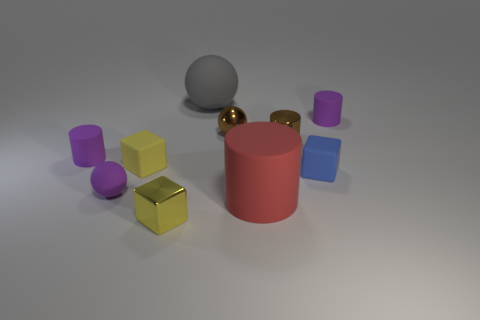How many purple cylinders must be subtracted to get 1 purple cylinders? 1 Subtract all tiny matte cubes. How many cubes are left? 1 Subtract all cyan blocks. How many purple cylinders are left? 2 Subtract all yellow cubes. How many cubes are left? 1 Subtract all cubes. How many objects are left? 7 Subtract all cyan cylinders. Subtract all green spheres. How many cylinders are left? 4 Subtract all small cubes. Subtract all big gray rubber objects. How many objects are left? 6 Add 9 brown shiny balls. How many brown shiny balls are left? 10 Add 3 small blue objects. How many small blue objects exist? 4 Subtract 0 gray blocks. How many objects are left? 10 